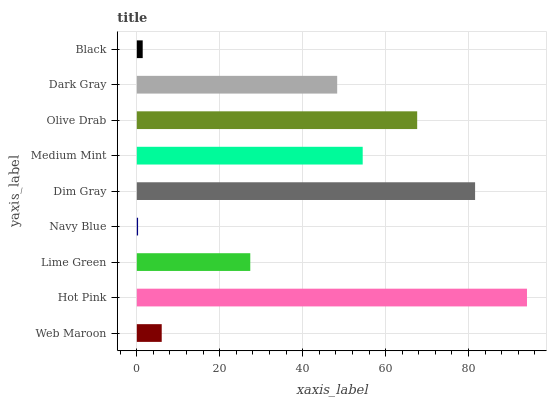Is Navy Blue the minimum?
Answer yes or no. Yes. Is Hot Pink the maximum?
Answer yes or no. Yes. Is Lime Green the minimum?
Answer yes or no. No. Is Lime Green the maximum?
Answer yes or no. No. Is Hot Pink greater than Lime Green?
Answer yes or no. Yes. Is Lime Green less than Hot Pink?
Answer yes or no. Yes. Is Lime Green greater than Hot Pink?
Answer yes or no. No. Is Hot Pink less than Lime Green?
Answer yes or no. No. Is Dark Gray the high median?
Answer yes or no. Yes. Is Dark Gray the low median?
Answer yes or no. Yes. Is Web Maroon the high median?
Answer yes or no. No. Is Hot Pink the low median?
Answer yes or no. No. 